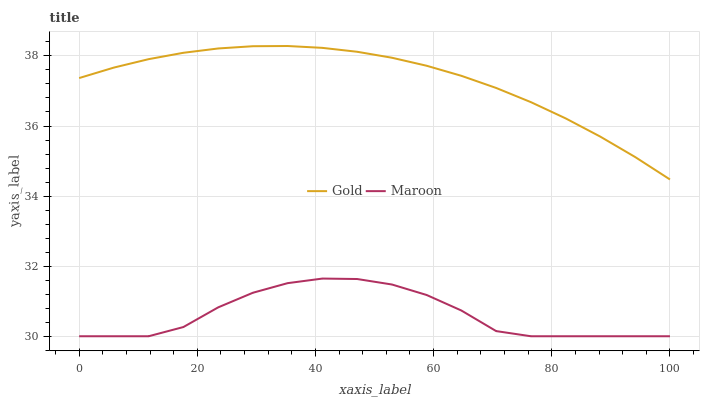Does Maroon have the minimum area under the curve?
Answer yes or no. Yes. Does Gold have the maximum area under the curve?
Answer yes or no. Yes. Does Gold have the minimum area under the curve?
Answer yes or no. No. Is Gold the smoothest?
Answer yes or no. Yes. Is Maroon the roughest?
Answer yes or no. Yes. Is Gold the roughest?
Answer yes or no. No. Does Maroon have the lowest value?
Answer yes or no. Yes. Does Gold have the lowest value?
Answer yes or no. No. Does Gold have the highest value?
Answer yes or no. Yes. Is Maroon less than Gold?
Answer yes or no. Yes. Is Gold greater than Maroon?
Answer yes or no. Yes. Does Maroon intersect Gold?
Answer yes or no. No. 